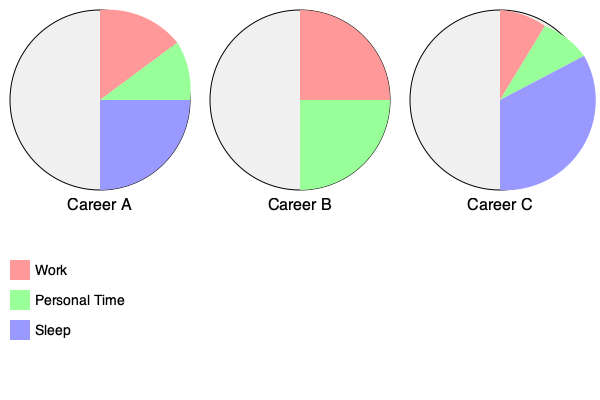Based on the pie charts representing work-life balance for three different careers, which career offers the most personal time? To determine which career offers the most personal time, we need to compare the green sections (representing personal time) in each pie chart:

1. Career A: The green section covers approximately 1/8 of the circle, or about 12.5% of the day.

2. Career B: The green section covers 1/2 of the circle, or 50% of the day.

3. Career C: The green section covers approximately 1/6 of the circle, or about 16.7% of the day.

Comparing these percentages:

Career B (50%) > Career C (16.7%) > Career A (12.5%)

Therefore, Career B offers the most personal time among the three options.
Answer: Career B 